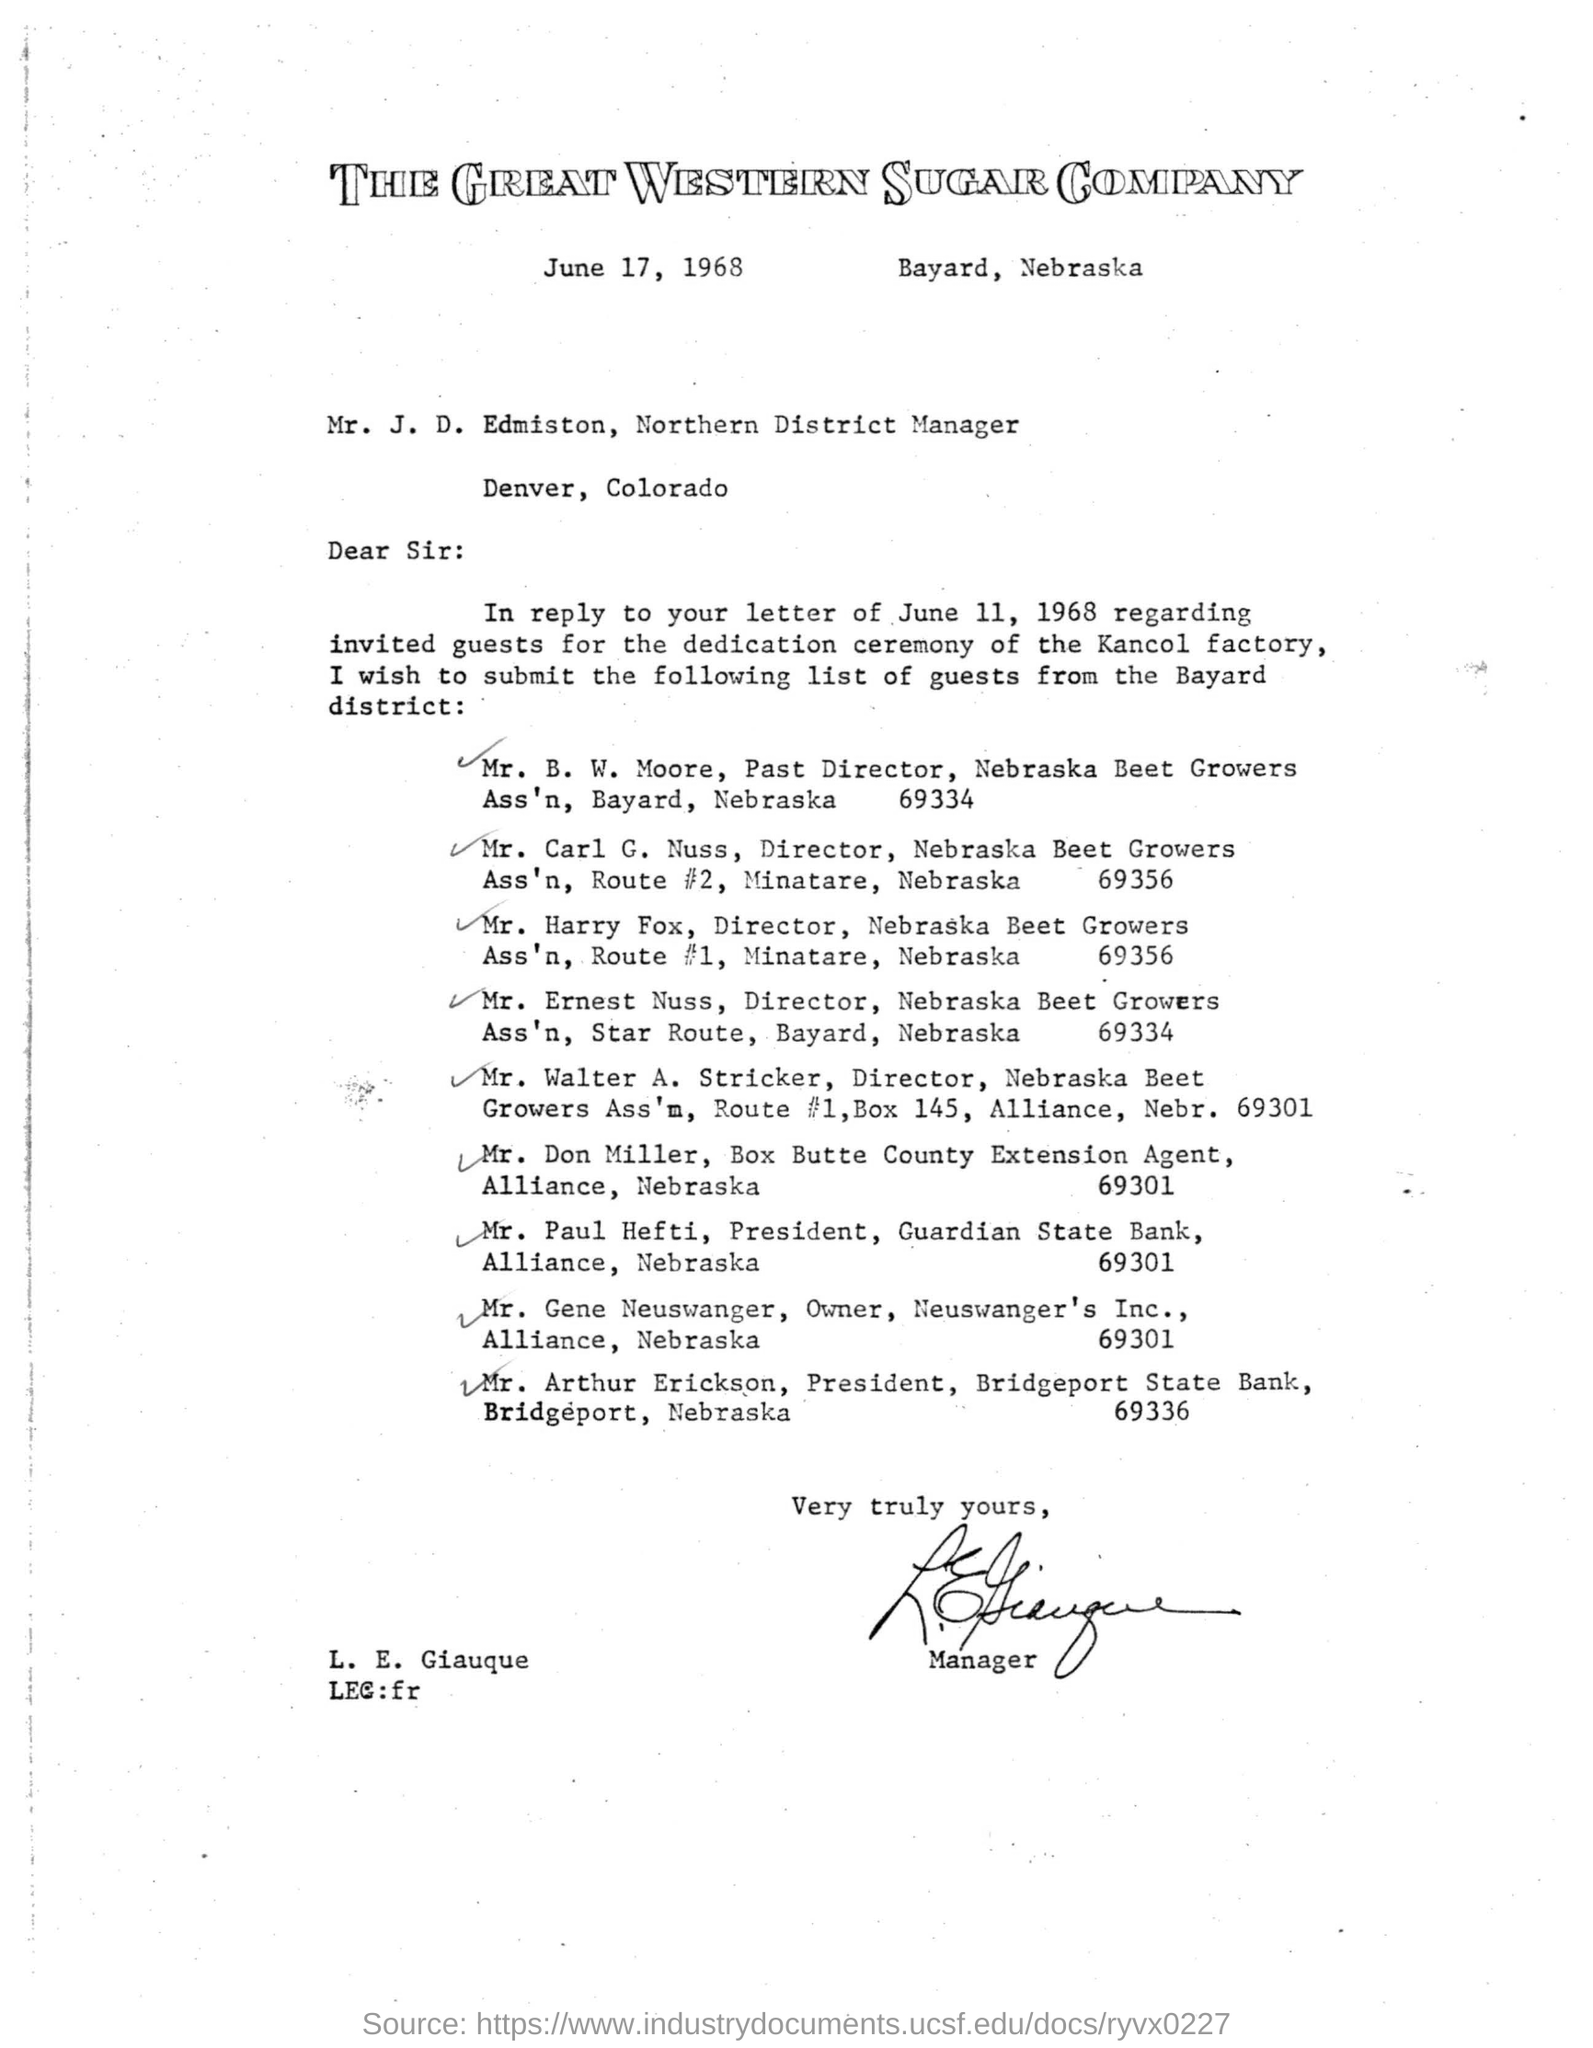Specify some key components in this picture. The issued date of the letter is June 17, 1968. The President of Bridgeport State Bank, Bridgeport, Nebraska, is Mr. Arthur Erickson. 